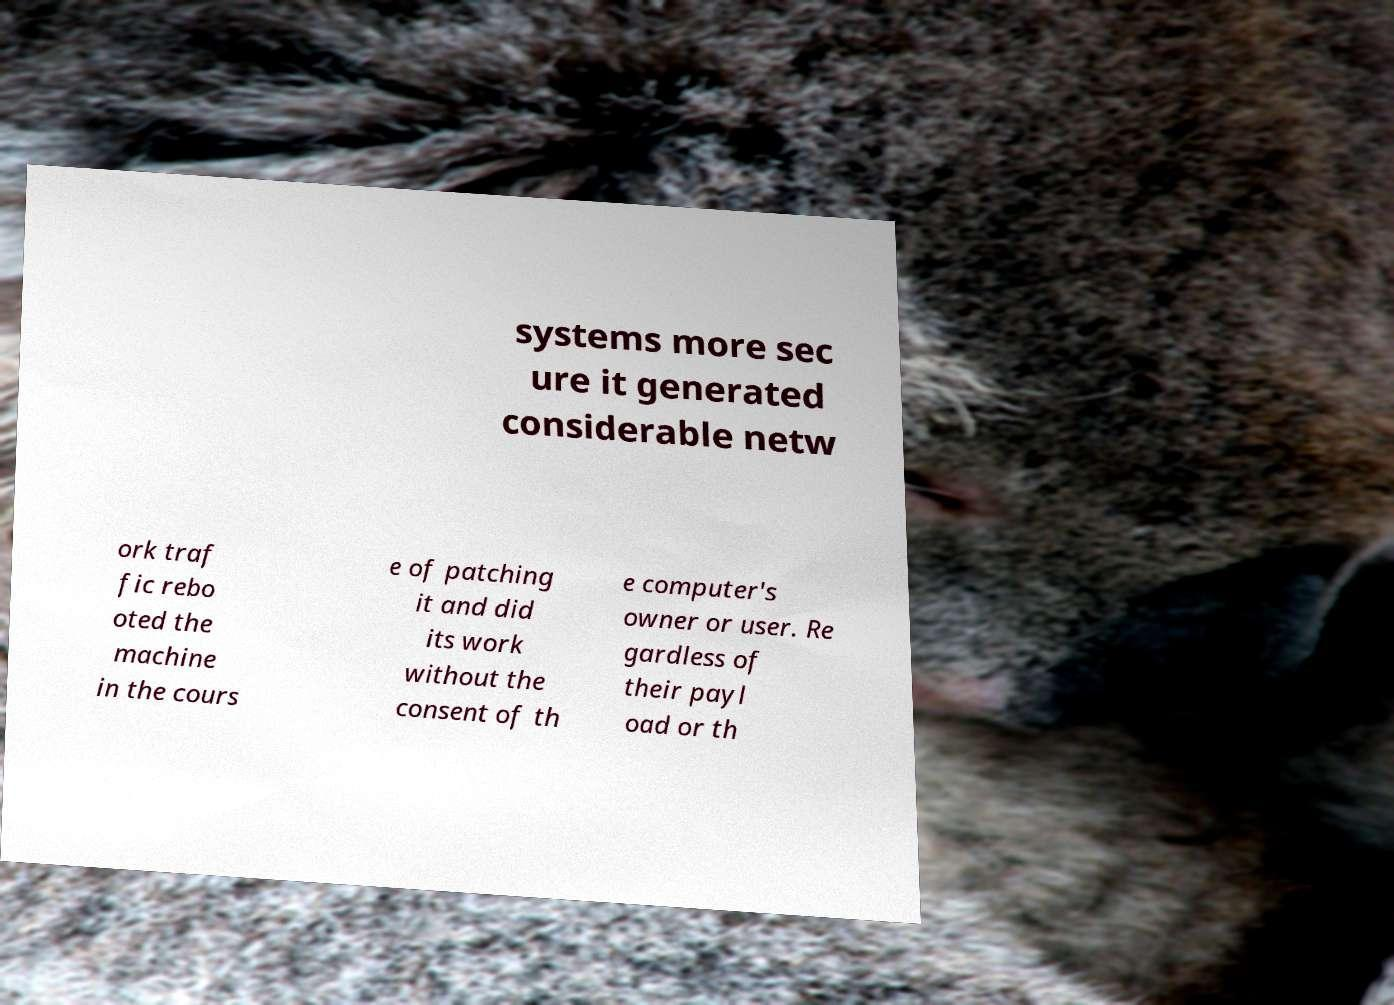Could you assist in decoding the text presented in this image and type it out clearly? systems more sec ure it generated considerable netw ork traf fic rebo oted the machine in the cours e of patching it and did its work without the consent of th e computer's owner or user. Re gardless of their payl oad or th 